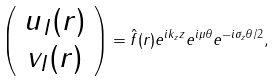<formula> <loc_0><loc_0><loc_500><loc_500>\left ( \begin{array} { c } u _ { I } ( { r } ) \\ v _ { I } ( { r } ) \end{array} \right ) = \hat { f } ( r ) e ^ { i k _ { z } z } e ^ { i \mu \theta } e ^ { - i \sigma _ { z } \theta / 2 } ,</formula> 